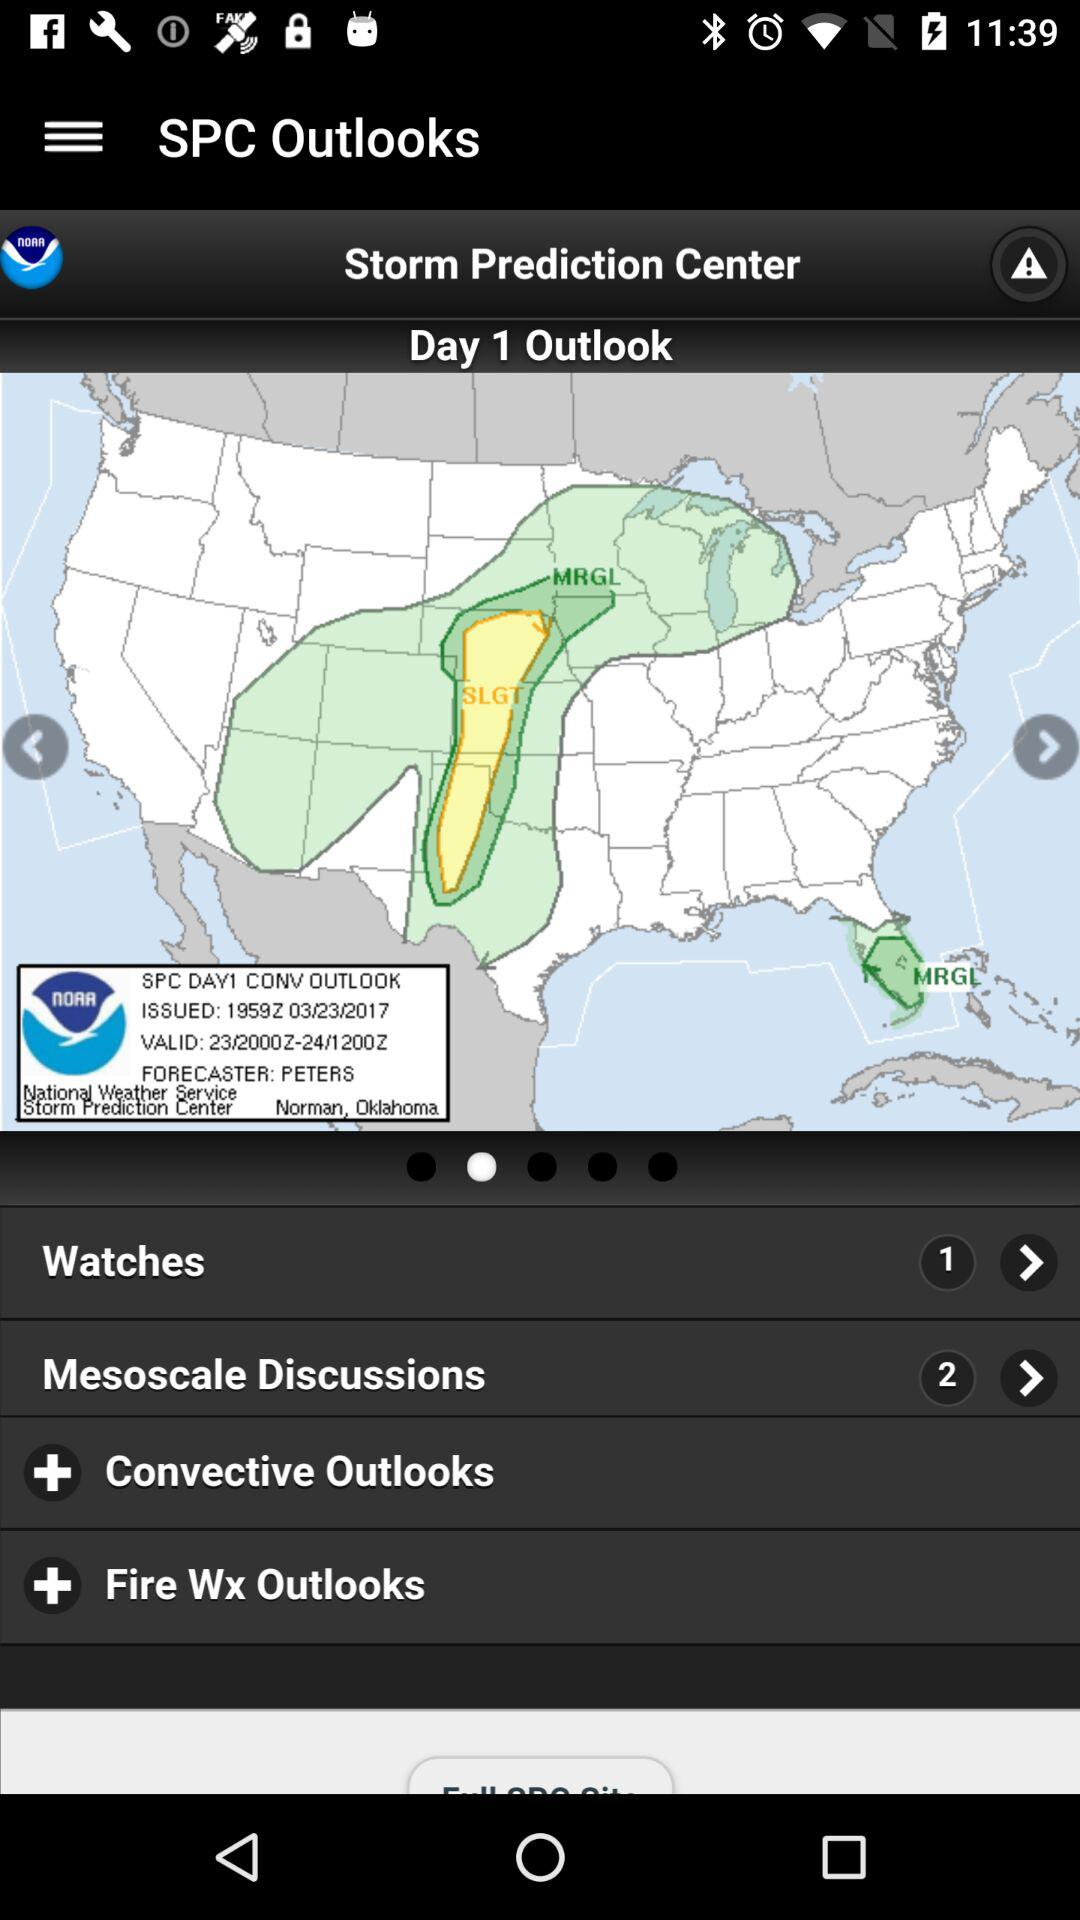What is the total count of watches? The total count of watches is 1. 